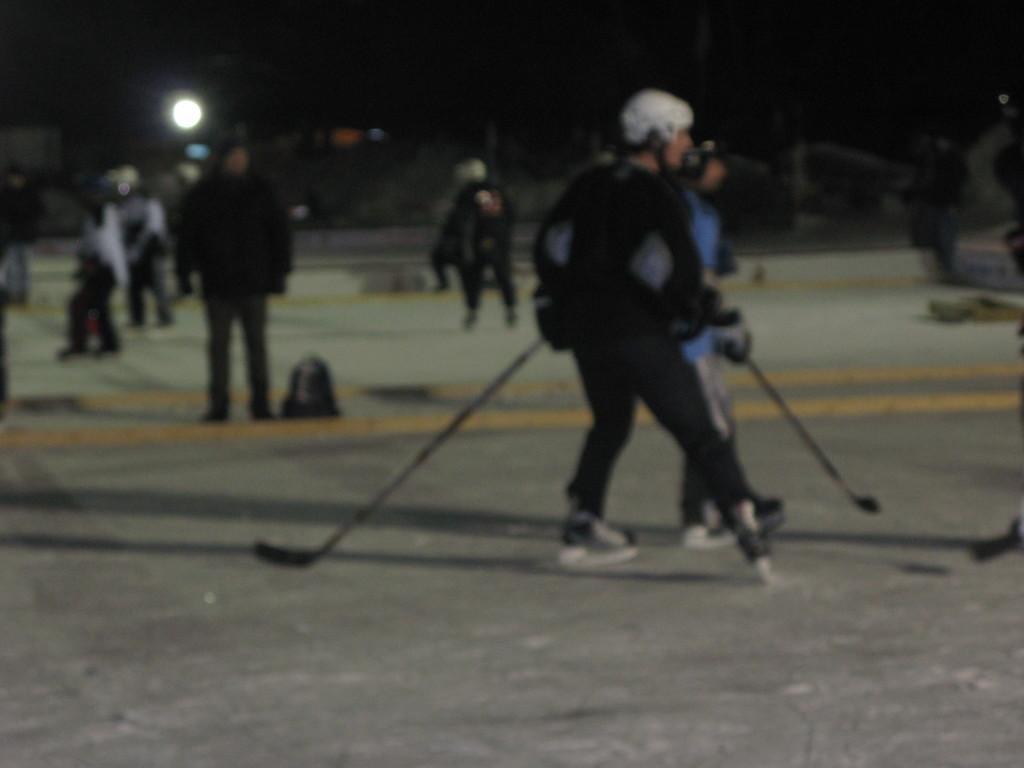Can you describe this image briefly? In this image in the foreground there are two people who are holding sticks, and it seems that they are playing something. And in the background there are a group of people, net, pole and some objects and light. At the bottom there is a walkway. 